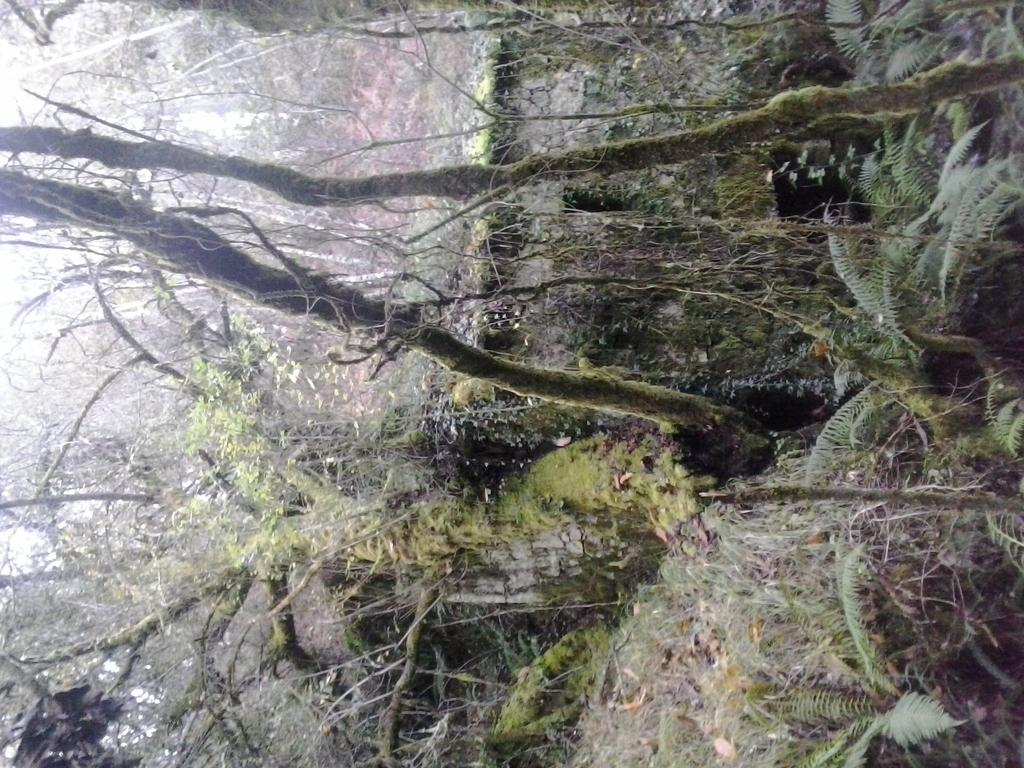What type of vegetation can be seen in the image? There are trees in the image. What type of question is being asked in the image? There is no question present in the image; it only features trees. 